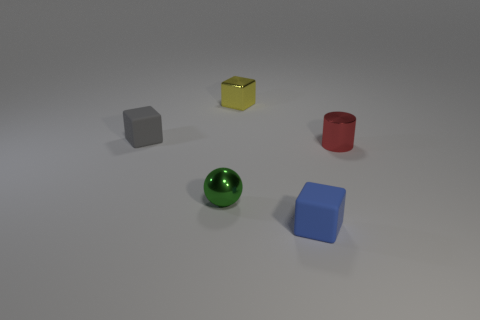Subtract all small blue blocks. How many blocks are left? 2 Add 3 green objects. How many objects exist? 8 Subtract all cubes. How many objects are left? 2 Subtract all green cubes. Subtract all yellow spheres. How many cubes are left? 3 Subtract all small objects. Subtract all big cyan metal cylinders. How many objects are left? 0 Add 5 tiny green spheres. How many tiny green spheres are left? 6 Add 3 yellow shiny cubes. How many yellow shiny cubes exist? 4 Subtract 0 yellow cylinders. How many objects are left? 5 